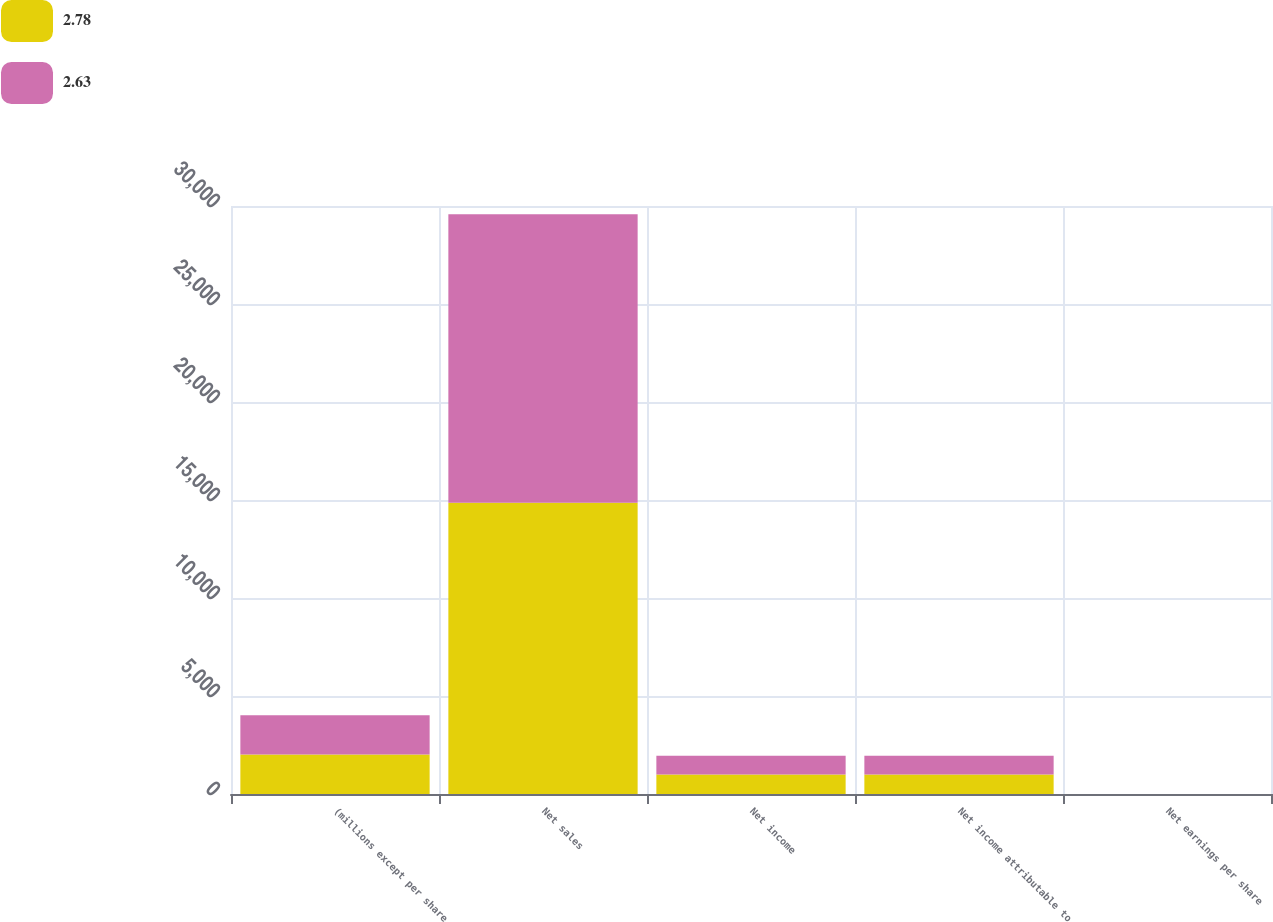Convert chart. <chart><loc_0><loc_0><loc_500><loc_500><stacked_bar_chart><ecel><fcel>(millions except per share<fcel>Net sales<fcel>Net income<fcel>Net income attributable to<fcel>Net earnings per share<nl><fcel>2.78<fcel>2012<fcel>14862<fcel>1001<fcel>1001<fcel>2.78<nl><fcel>2.63<fcel>2011<fcel>14722<fcel>954<fcel>956<fcel>2.63<nl></chart> 